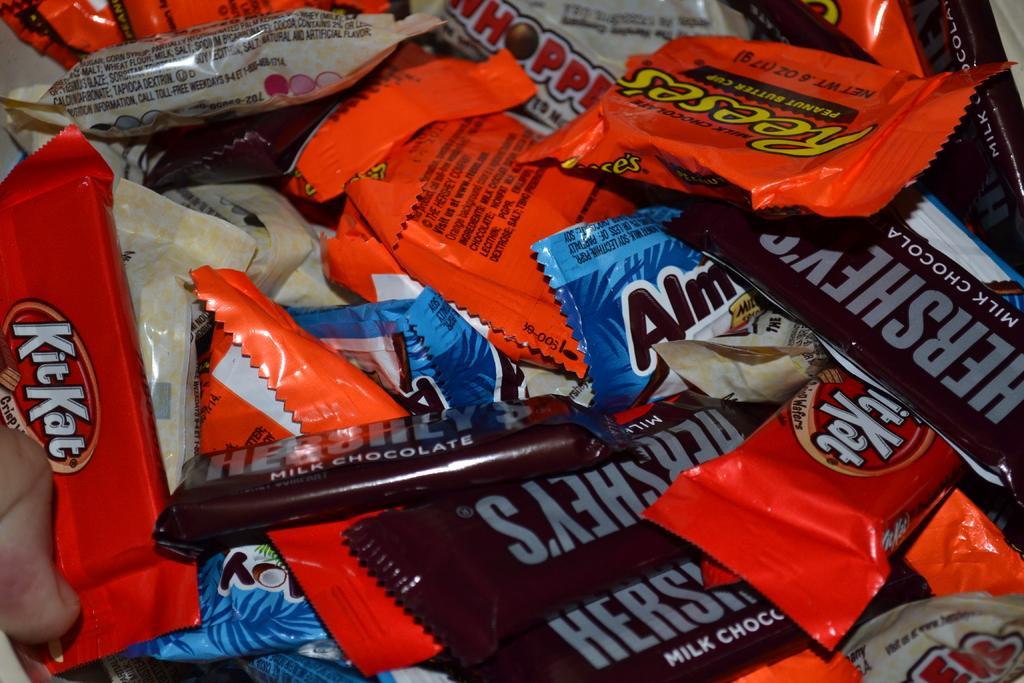Please provide a concise description of this image. In this image I can see number of chocolate packets which are brown, orange, blue and black in color. I can see few of them are cream in color. 